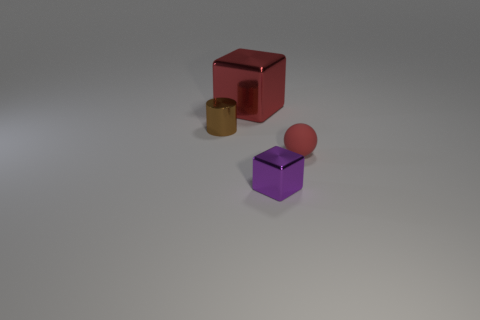Add 3 small shiny things. How many objects exist? 7 Subtract all spheres. How many objects are left? 3 Subtract all brown things. Subtract all rubber objects. How many objects are left? 2 Add 3 big objects. How many big objects are left? 4 Add 2 small blue cylinders. How many small blue cylinders exist? 2 Subtract 1 brown cylinders. How many objects are left? 3 